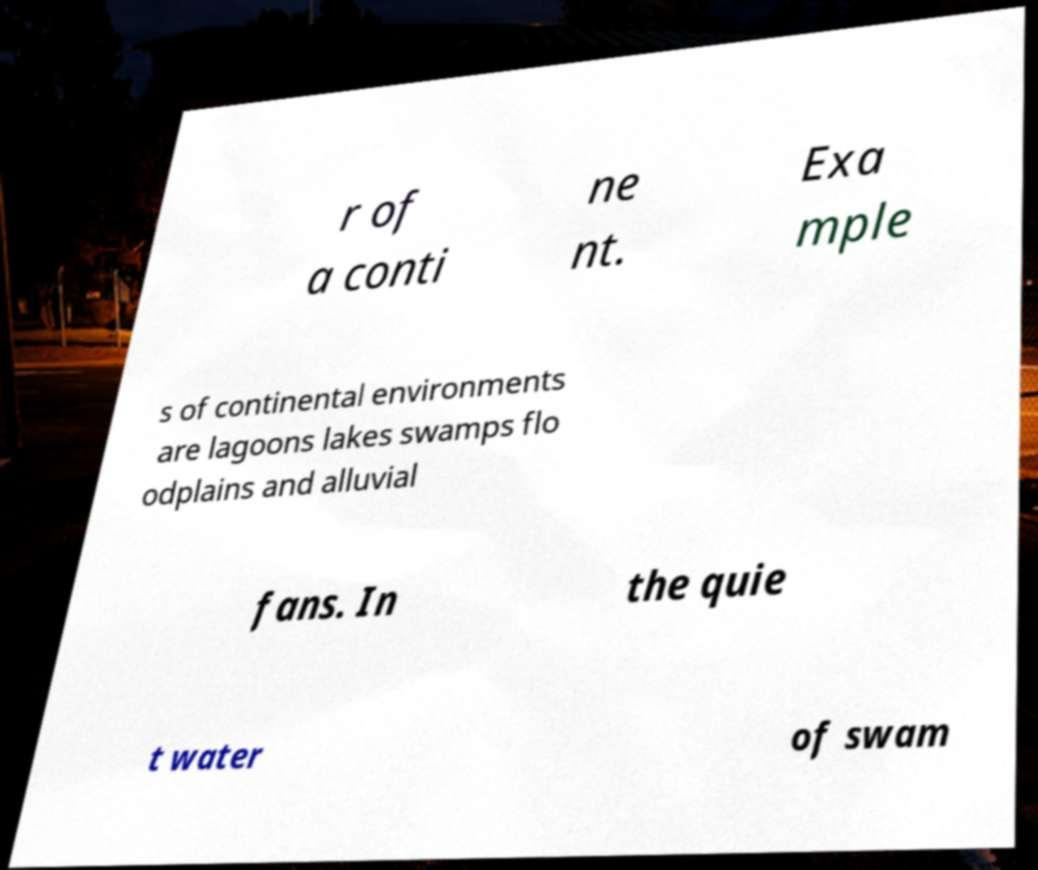For documentation purposes, I need the text within this image transcribed. Could you provide that? r of a conti ne nt. Exa mple s of continental environments are lagoons lakes swamps flo odplains and alluvial fans. In the quie t water of swam 